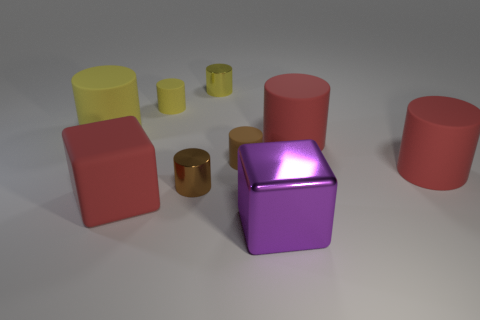Subtract all metal cylinders. How many cylinders are left? 5 Add 1 cyan matte blocks. How many objects exist? 10 Subtract all red cylinders. How many cylinders are left? 5 Subtract all green cubes. How many brown cylinders are left? 2 Subtract all blocks. How many objects are left? 7 Subtract 2 blocks. How many blocks are left? 0 Subtract all small yellow matte objects. Subtract all blue spheres. How many objects are left? 8 Add 1 small brown rubber things. How many small brown rubber things are left? 2 Add 5 red cubes. How many red cubes exist? 6 Subtract 2 yellow cylinders. How many objects are left? 7 